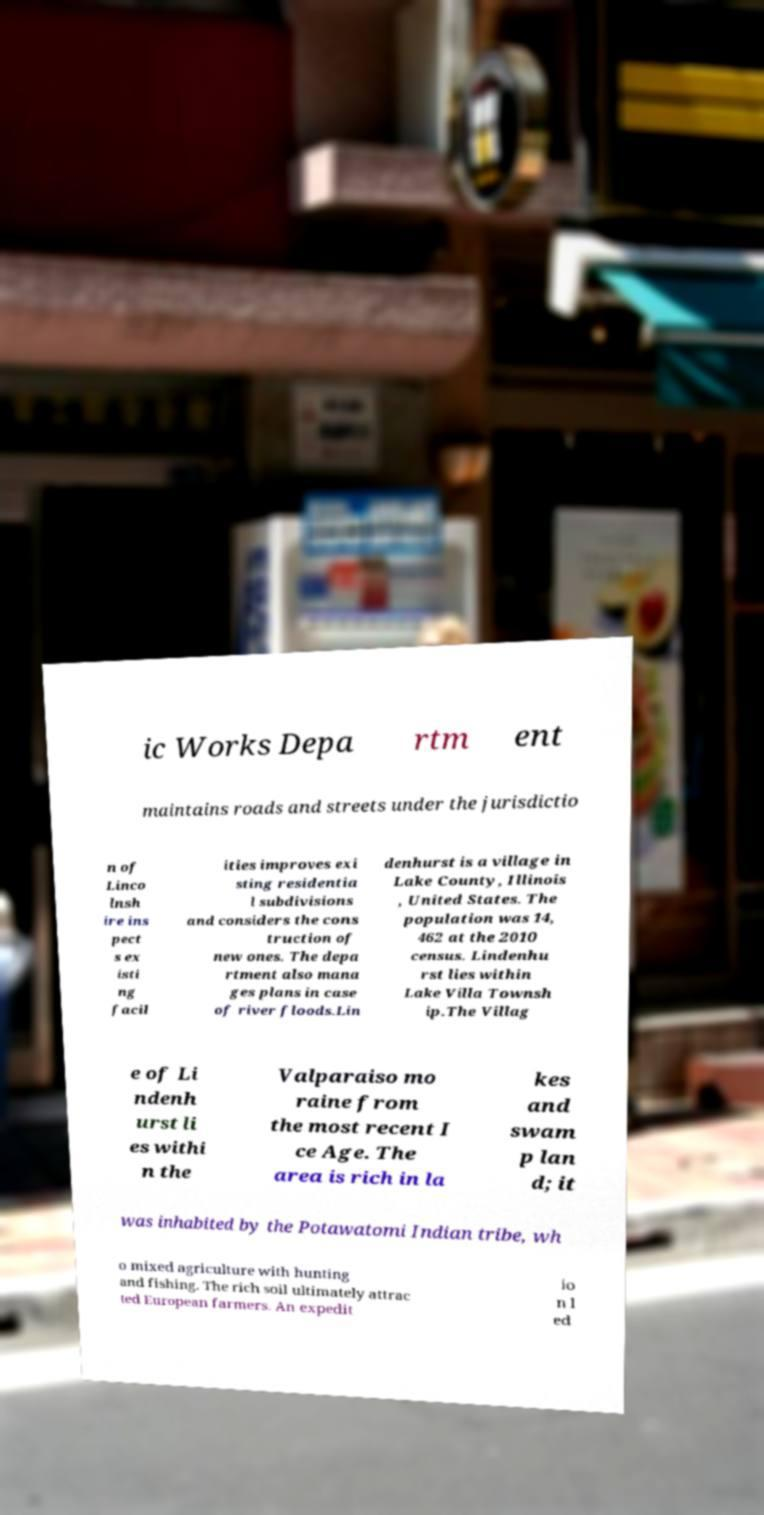There's text embedded in this image that I need extracted. Can you transcribe it verbatim? ic Works Depa rtm ent maintains roads and streets under the jurisdictio n of Linco lnsh ire ins pect s ex isti ng facil ities improves exi sting residentia l subdivisions and considers the cons truction of new ones. The depa rtment also mana ges plans in case of river floods.Lin denhurst is a village in Lake County, Illinois , United States. The population was 14, 462 at the 2010 census. Lindenhu rst lies within Lake Villa Townsh ip.The Villag e of Li ndenh urst li es withi n the Valparaiso mo raine from the most recent I ce Age. The area is rich in la kes and swam p lan d; it was inhabited by the Potawatomi Indian tribe, wh o mixed agriculture with hunting and fishing. The rich soil ultimately attrac ted European farmers. An expedit io n l ed 